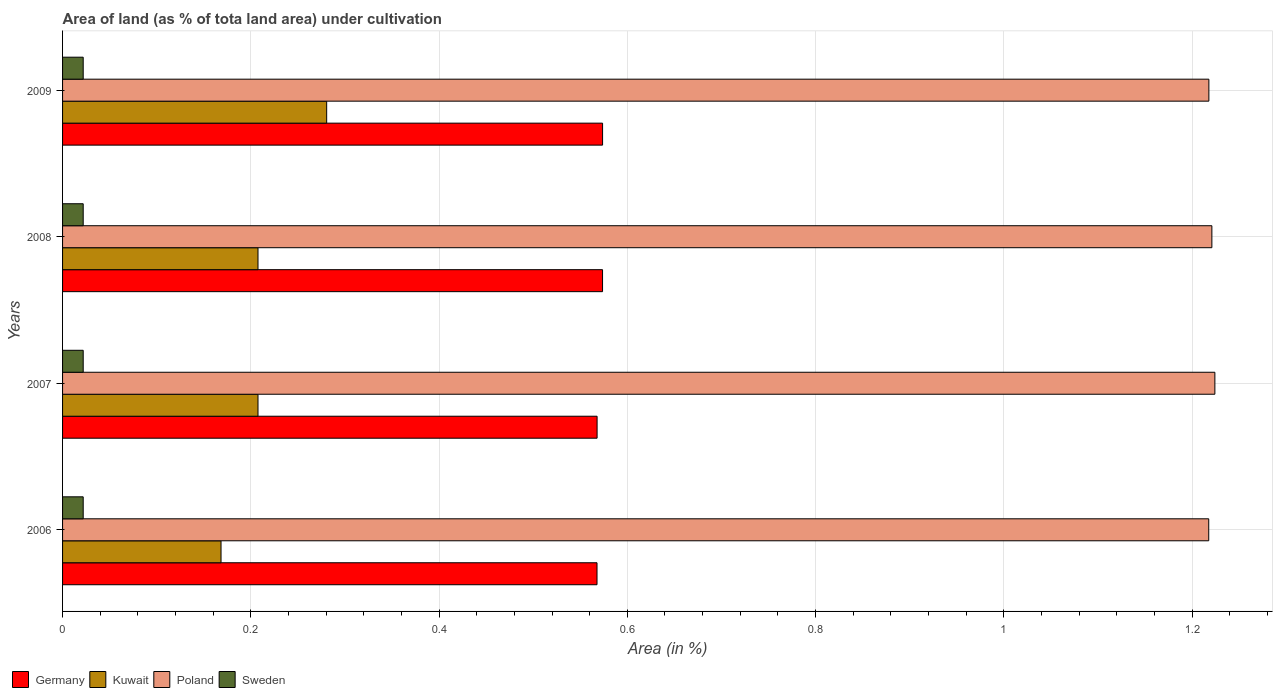How many different coloured bars are there?
Your response must be concise. 4. How many groups of bars are there?
Ensure brevity in your answer.  4. What is the label of the 2nd group of bars from the top?
Offer a very short reply. 2008. In how many cases, is the number of bars for a given year not equal to the number of legend labels?
Ensure brevity in your answer.  0. What is the percentage of land under cultivation in Poland in 2008?
Make the answer very short. 1.22. Across all years, what is the maximum percentage of land under cultivation in Germany?
Provide a short and direct response. 0.57. Across all years, what is the minimum percentage of land under cultivation in Kuwait?
Your response must be concise. 0.17. What is the total percentage of land under cultivation in Sweden in the graph?
Your response must be concise. 0.09. What is the difference between the percentage of land under cultivation in Sweden in 2007 and that in 2008?
Your answer should be compact. 0. What is the difference between the percentage of land under cultivation in Sweden in 2009 and the percentage of land under cultivation in Germany in 2008?
Give a very brief answer. -0.55. What is the average percentage of land under cultivation in Poland per year?
Give a very brief answer. 1.22. In the year 2007, what is the difference between the percentage of land under cultivation in Sweden and percentage of land under cultivation in Kuwait?
Provide a short and direct response. -0.19. In how many years, is the percentage of land under cultivation in Sweden greater than 0.52 %?
Your answer should be very brief. 0. What is the ratio of the percentage of land under cultivation in Germany in 2006 to that in 2007?
Your answer should be very brief. 1. Is the percentage of land under cultivation in Sweden in 2008 less than that in 2009?
Provide a succinct answer. No. What is the difference between the highest and the second highest percentage of land under cultivation in Kuwait?
Your answer should be compact. 0.07. What is the difference between the highest and the lowest percentage of land under cultivation in Sweden?
Provide a short and direct response. 0. In how many years, is the percentage of land under cultivation in Kuwait greater than the average percentage of land under cultivation in Kuwait taken over all years?
Offer a terse response. 1. What does the 1st bar from the top in 2009 represents?
Ensure brevity in your answer.  Sweden. What does the 1st bar from the bottom in 2006 represents?
Offer a terse response. Germany. Are all the bars in the graph horizontal?
Ensure brevity in your answer.  Yes. How many years are there in the graph?
Provide a short and direct response. 4. What is the difference between two consecutive major ticks on the X-axis?
Give a very brief answer. 0.2. Does the graph contain any zero values?
Your response must be concise. No. Does the graph contain grids?
Provide a short and direct response. Yes. How are the legend labels stacked?
Offer a very short reply. Horizontal. What is the title of the graph?
Offer a terse response. Area of land (as % of tota land area) under cultivation. Does "El Salvador" appear as one of the legend labels in the graph?
Your answer should be very brief. No. What is the label or title of the X-axis?
Give a very brief answer. Area (in %). What is the Area (in %) in Germany in 2006?
Keep it short and to the point. 0.57. What is the Area (in %) in Kuwait in 2006?
Provide a short and direct response. 0.17. What is the Area (in %) in Poland in 2006?
Give a very brief answer. 1.22. What is the Area (in %) of Sweden in 2006?
Provide a short and direct response. 0.02. What is the Area (in %) in Germany in 2007?
Provide a short and direct response. 0.57. What is the Area (in %) of Kuwait in 2007?
Your answer should be very brief. 0.21. What is the Area (in %) in Poland in 2007?
Offer a terse response. 1.22. What is the Area (in %) in Sweden in 2007?
Provide a succinct answer. 0.02. What is the Area (in %) in Germany in 2008?
Give a very brief answer. 0.57. What is the Area (in %) of Kuwait in 2008?
Provide a short and direct response. 0.21. What is the Area (in %) of Poland in 2008?
Offer a very short reply. 1.22. What is the Area (in %) of Sweden in 2008?
Provide a short and direct response. 0.02. What is the Area (in %) of Germany in 2009?
Your answer should be very brief. 0.57. What is the Area (in %) of Kuwait in 2009?
Your answer should be compact. 0.28. What is the Area (in %) in Poland in 2009?
Your answer should be very brief. 1.22. What is the Area (in %) in Sweden in 2009?
Your answer should be compact. 0.02. Across all years, what is the maximum Area (in %) of Germany?
Keep it short and to the point. 0.57. Across all years, what is the maximum Area (in %) of Kuwait?
Offer a terse response. 0.28. Across all years, what is the maximum Area (in %) of Poland?
Ensure brevity in your answer.  1.22. Across all years, what is the maximum Area (in %) of Sweden?
Make the answer very short. 0.02. Across all years, what is the minimum Area (in %) of Germany?
Ensure brevity in your answer.  0.57. Across all years, what is the minimum Area (in %) in Kuwait?
Your answer should be compact. 0.17. Across all years, what is the minimum Area (in %) of Poland?
Provide a succinct answer. 1.22. Across all years, what is the minimum Area (in %) in Sweden?
Ensure brevity in your answer.  0.02. What is the total Area (in %) of Germany in the graph?
Your answer should be very brief. 2.28. What is the total Area (in %) of Kuwait in the graph?
Provide a succinct answer. 0.86. What is the total Area (in %) in Poland in the graph?
Offer a very short reply. 4.88. What is the total Area (in %) in Sweden in the graph?
Offer a very short reply. 0.09. What is the difference between the Area (in %) of Germany in 2006 and that in 2007?
Offer a very short reply. -0. What is the difference between the Area (in %) in Kuwait in 2006 and that in 2007?
Offer a very short reply. -0.04. What is the difference between the Area (in %) in Poland in 2006 and that in 2007?
Offer a very short reply. -0.01. What is the difference between the Area (in %) in Sweden in 2006 and that in 2007?
Offer a very short reply. 0. What is the difference between the Area (in %) of Germany in 2006 and that in 2008?
Your response must be concise. -0.01. What is the difference between the Area (in %) in Kuwait in 2006 and that in 2008?
Keep it short and to the point. -0.04. What is the difference between the Area (in %) in Poland in 2006 and that in 2008?
Provide a short and direct response. -0. What is the difference between the Area (in %) in Germany in 2006 and that in 2009?
Keep it short and to the point. -0.01. What is the difference between the Area (in %) in Kuwait in 2006 and that in 2009?
Offer a terse response. -0.11. What is the difference between the Area (in %) of Poland in 2006 and that in 2009?
Provide a succinct answer. -0. What is the difference between the Area (in %) in Germany in 2007 and that in 2008?
Offer a very short reply. -0.01. What is the difference between the Area (in %) of Poland in 2007 and that in 2008?
Provide a short and direct response. 0. What is the difference between the Area (in %) in Sweden in 2007 and that in 2008?
Your answer should be compact. 0. What is the difference between the Area (in %) of Germany in 2007 and that in 2009?
Make the answer very short. -0.01. What is the difference between the Area (in %) in Kuwait in 2007 and that in 2009?
Offer a very short reply. -0.07. What is the difference between the Area (in %) of Poland in 2007 and that in 2009?
Give a very brief answer. 0.01. What is the difference between the Area (in %) in Kuwait in 2008 and that in 2009?
Your answer should be very brief. -0.07. What is the difference between the Area (in %) of Poland in 2008 and that in 2009?
Provide a succinct answer. 0. What is the difference between the Area (in %) of Sweden in 2008 and that in 2009?
Your response must be concise. 0. What is the difference between the Area (in %) in Germany in 2006 and the Area (in %) in Kuwait in 2007?
Your answer should be compact. 0.36. What is the difference between the Area (in %) of Germany in 2006 and the Area (in %) of Poland in 2007?
Offer a terse response. -0.66. What is the difference between the Area (in %) in Germany in 2006 and the Area (in %) in Sweden in 2007?
Provide a succinct answer. 0.55. What is the difference between the Area (in %) of Kuwait in 2006 and the Area (in %) of Poland in 2007?
Keep it short and to the point. -1.06. What is the difference between the Area (in %) in Kuwait in 2006 and the Area (in %) in Sweden in 2007?
Make the answer very short. 0.15. What is the difference between the Area (in %) of Poland in 2006 and the Area (in %) of Sweden in 2007?
Provide a succinct answer. 1.2. What is the difference between the Area (in %) of Germany in 2006 and the Area (in %) of Kuwait in 2008?
Make the answer very short. 0.36. What is the difference between the Area (in %) of Germany in 2006 and the Area (in %) of Poland in 2008?
Provide a short and direct response. -0.65. What is the difference between the Area (in %) of Germany in 2006 and the Area (in %) of Sweden in 2008?
Ensure brevity in your answer.  0.55. What is the difference between the Area (in %) in Kuwait in 2006 and the Area (in %) in Poland in 2008?
Offer a terse response. -1.05. What is the difference between the Area (in %) of Kuwait in 2006 and the Area (in %) of Sweden in 2008?
Your answer should be very brief. 0.15. What is the difference between the Area (in %) in Poland in 2006 and the Area (in %) in Sweden in 2008?
Your answer should be compact. 1.2. What is the difference between the Area (in %) of Germany in 2006 and the Area (in %) of Kuwait in 2009?
Offer a very short reply. 0.29. What is the difference between the Area (in %) in Germany in 2006 and the Area (in %) in Poland in 2009?
Keep it short and to the point. -0.65. What is the difference between the Area (in %) of Germany in 2006 and the Area (in %) of Sweden in 2009?
Ensure brevity in your answer.  0.55. What is the difference between the Area (in %) in Kuwait in 2006 and the Area (in %) in Poland in 2009?
Provide a succinct answer. -1.05. What is the difference between the Area (in %) in Kuwait in 2006 and the Area (in %) in Sweden in 2009?
Keep it short and to the point. 0.15. What is the difference between the Area (in %) in Poland in 2006 and the Area (in %) in Sweden in 2009?
Your answer should be very brief. 1.2. What is the difference between the Area (in %) in Germany in 2007 and the Area (in %) in Kuwait in 2008?
Your response must be concise. 0.36. What is the difference between the Area (in %) of Germany in 2007 and the Area (in %) of Poland in 2008?
Provide a succinct answer. -0.65. What is the difference between the Area (in %) in Germany in 2007 and the Area (in %) in Sweden in 2008?
Make the answer very short. 0.55. What is the difference between the Area (in %) of Kuwait in 2007 and the Area (in %) of Poland in 2008?
Make the answer very short. -1.01. What is the difference between the Area (in %) in Kuwait in 2007 and the Area (in %) in Sweden in 2008?
Offer a very short reply. 0.19. What is the difference between the Area (in %) in Poland in 2007 and the Area (in %) in Sweden in 2008?
Make the answer very short. 1.2. What is the difference between the Area (in %) of Germany in 2007 and the Area (in %) of Kuwait in 2009?
Your answer should be very brief. 0.29. What is the difference between the Area (in %) in Germany in 2007 and the Area (in %) in Poland in 2009?
Keep it short and to the point. -0.65. What is the difference between the Area (in %) of Germany in 2007 and the Area (in %) of Sweden in 2009?
Your response must be concise. 0.55. What is the difference between the Area (in %) of Kuwait in 2007 and the Area (in %) of Poland in 2009?
Your response must be concise. -1.01. What is the difference between the Area (in %) in Kuwait in 2007 and the Area (in %) in Sweden in 2009?
Make the answer very short. 0.19. What is the difference between the Area (in %) of Poland in 2007 and the Area (in %) of Sweden in 2009?
Give a very brief answer. 1.2. What is the difference between the Area (in %) of Germany in 2008 and the Area (in %) of Kuwait in 2009?
Your answer should be compact. 0.29. What is the difference between the Area (in %) of Germany in 2008 and the Area (in %) of Poland in 2009?
Your answer should be compact. -0.64. What is the difference between the Area (in %) in Germany in 2008 and the Area (in %) in Sweden in 2009?
Your response must be concise. 0.55. What is the difference between the Area (in %) in Kuwait in 2008 and the Area (in %) in Poland in 2009?
Offer a very short reply. -1.01. What is the difference between the Area (in %) in Kuwait in 2008 and the Area (in %) in Sweden in 2009?
Provide a short and direct response. 0.19. What is the difference between the Area (in %) of Poland in 2008 and the Area (in %) of Sweden in 2009?
Offer a terse response. 1.2. What is the average Area (in %) of Germany per year?
Your response must be concise. 0.57. What is the average Area (in %) in Kuwait per year?
Your response must be concise. 0.22. What is the average Area (in %) of Poland per year?
Ensure brevity in your answer.  1.22. What is the average Area (in %) in Sweden per year?
Your answer should be very brief. 0.02. In the year 2006, what is the difference between the Area (in %) in Germany and Area (in %) in Kuwait?
Offer a very short reply. 0.4. In the year 2006, what is the difference between the Area (in %) in Germany and Area (in %) in Poland?
Provide a succinct answer. -0.65. In the year 2006, what is the difference between the Area (in %) of Germany and Area (in %) of Sweden?
Offer a terse response. 0.55. In the year 2006, what is the difference between the Area (in %) of Kuwait and Area (in %) of Poland?
Your answer should be compact. -1.05. In the year 2006, what is the difference between the Area (in %) in Kuwait and Area (in %) in Sweden?
Your answer should be very brief. 0.15. In the year 2006, what is the difference between the Area (in %) in Poland and Area (in %) in Sweden?
Provide a succinct answer. 1.2. In the year 2007, what is the difference between the Area (in %) in Germany and Area (in %) in Kuwait?
Your answer should be compact. 0.36. In the year 2007, what is the difference between the Area (in %) of Germany and Area (in %) of Poland?
Make the answer very short. -0.66. In the year 2007, what is the difference between the Area (in %) in Germany and Area (in %) in Sweden?
Your response must be concise. 0.55. In the year 2007, what is the difference between the Area (in %) of Kuwait and Area (in %) of Poland?
Offer a very short reply. -1.02. In the year 2007, what is the difference between the Area (in %) of Kuwait and Area (in %) of Sweden?
Your answer should be very brief. 0.19. In the year 2007, what is the difference between the Area (in %) in Poland and Area (in %) in Sweden?
Your response must be concise. 1.2. In the year 2008, what is the difference between the Area (in %) in Germany and Area (in %) in Kuwait?
Give a very brief answer. 0.37. In the year 2008, what is the difference between the Area (in %) in Germany and Area (in %) in Poland?
Keep it short and to the point. -0.65. In the year 2008, what is the difference between the Area (in %) of Germany and Area (in %) of Sweden?
Give a very brief answer. 0.55. In the year 2008, what is the difference between the Area (in %) in Kuwait and Area (in %) in Poland?
Provide a succinct answer. -1.01. In the year 2008, what is the difference between the Area (in %) of Kuwait and Area (in %) of Sweden?
Offer a terse response. 0.19. In the year 2008, what is the difference between the Area (in %) in Poland and Area (in %) in Sweden?
Make the answer very short. 1.2. In the year 2009, what is the difference between the Area (in %) in Germany and Area (in %) in Kuwait?
Make the answer very short. 0.29. In the year 2009, what is the difference between the Area (in %) in Germany and Area (in %) in Poland?
Provide a succinct answer. -0.64. In the year 2009, what is the difference between the Area (in %) of Germany and Area (in %) of Sweden?
Make the answer very short. 0.55. In the year 2009, what is the difference between the Area (in %) in Kuwait and Area (in %) in Poland?
Offer a terse response. -0.94. In the year 2009, what is the difference between the Area (in %) of Kuwait and Area (in %) of Sweden?
Your response must be concise. 0.26. In the year 2009, what is the difference between the Area (in %) of Poland and Area (in %) of Sweden?
Your response must be concise. 1.2. What is the ratio of the Area (in %) in Kuwait in 2006 to that in 2007?
Provide a short and direct response. 0.81. What is the ratio of the Area (in %) of Sweden in 2006 to that in 2007?
Your answer should be very brief. 1. What is the ratio of the Area (in %) in Kuwait in 2006 to that in 2008?
Offer a very short reply. 0.81. What is the ratio of the Area (in %) of Poland in 2006 to that in 2008?
Offer a very short reply. 1. What is the ratio of the Area (in %) in Germany in 2006 to that in 2009?
Offer a very short reply. 0.99. What is the ratio of the Area (in %) of Poland in 2006 to that in 2009?
Offer a terse response. 1. What is the ratio of the Area (in %) in Kuwait in 2007 to that in 2008?
Provide a short and direct response. 1. What is the ratio of the Area (in %) in Sweden in 2007 to that in 2008?
Ensure brevity in your answer.  1. What is the ratio of the Area (in %) in Kuwait in 2007 to that in 2009?
Your response must be concise. 0.74. What is the ratio of the Area (in %) of Poland in 2007 to that in 2009?
Make the answer very short. 1.01. What is the ratio of the Area (in %) in Kuwait in 2008 to that in 2009?
Your answer should be very brief. 0.74. What is the ratio of the Area (in %) in Poland in 2008 to that in 2009?
Offer a very short reply. 1. What is the ratio of the Area (in %) of Sweden in 2008 to that in 2009?
Your answer should be very brief. 1. What is the difference between the highest and the second highest Area (in %) of Germany?
Keep it short and to the point. 0. What is the difference between the highest and the second highest Area (in %) in Kuwait?
Your response must be concise. 0.07. What is the difference between the highest and the second highest Area (in %) of Poland?
Provide a short and direct response. 0. What is the difference between the highest and the second highest Area (in %) of Sweden?
Your answer should be compact. 0. What is the difference between the highest and the lowest Area (in %) in Germany?
Give a very brief answer. 0.01. What is the difference between the highest and the lowest Area (in %) in Kuwait?
Keep it short and to the point. 0.11. What is the difference between the highest and the lowest Area (in %) of Poland?
Provide a short and direct response. 0.01. What is the difference between the highest and the lowest Area (in %) of Sweden?
Your answer should be very brief. 0. 